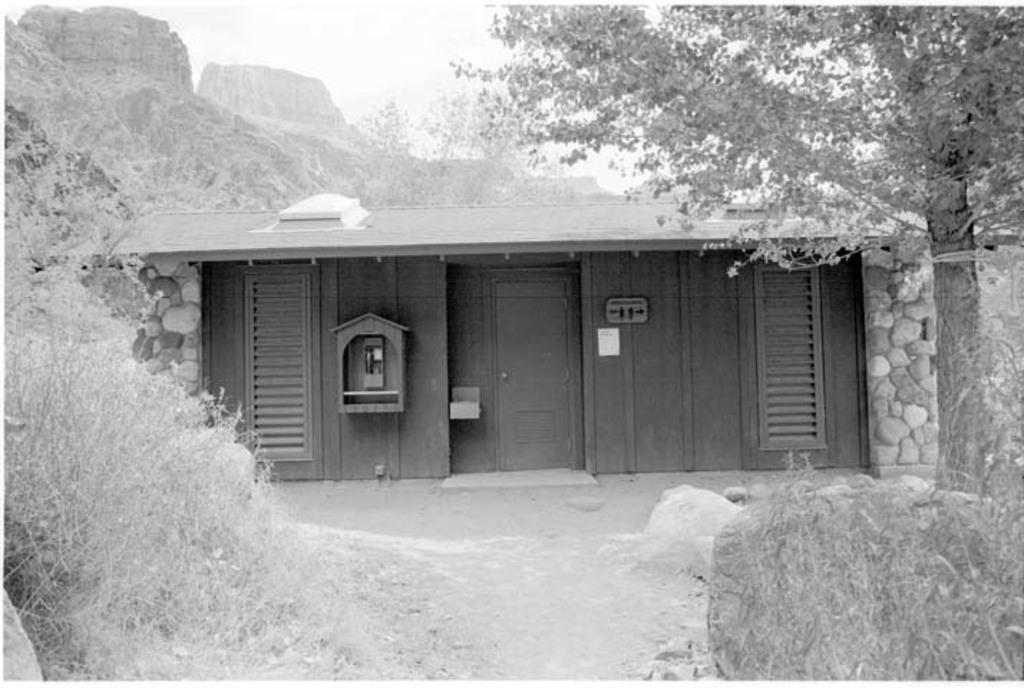What is the color scheme of the image? The image is black and white. What type of natural elements can be seen in the image? There are plants, rocks, and trees visible in the image. What type of structure is present in the image? There is a wooden house in the image. What geographical features can be seen in the image? Rock hills are visible in the image. What is visible in the background of the image? The sky is visible in the background of the image. How much profit can be made from the plants in the image? There is no mention of profit or any economic aspect in the image, so it is not possible to determine the profitability of the plants. 